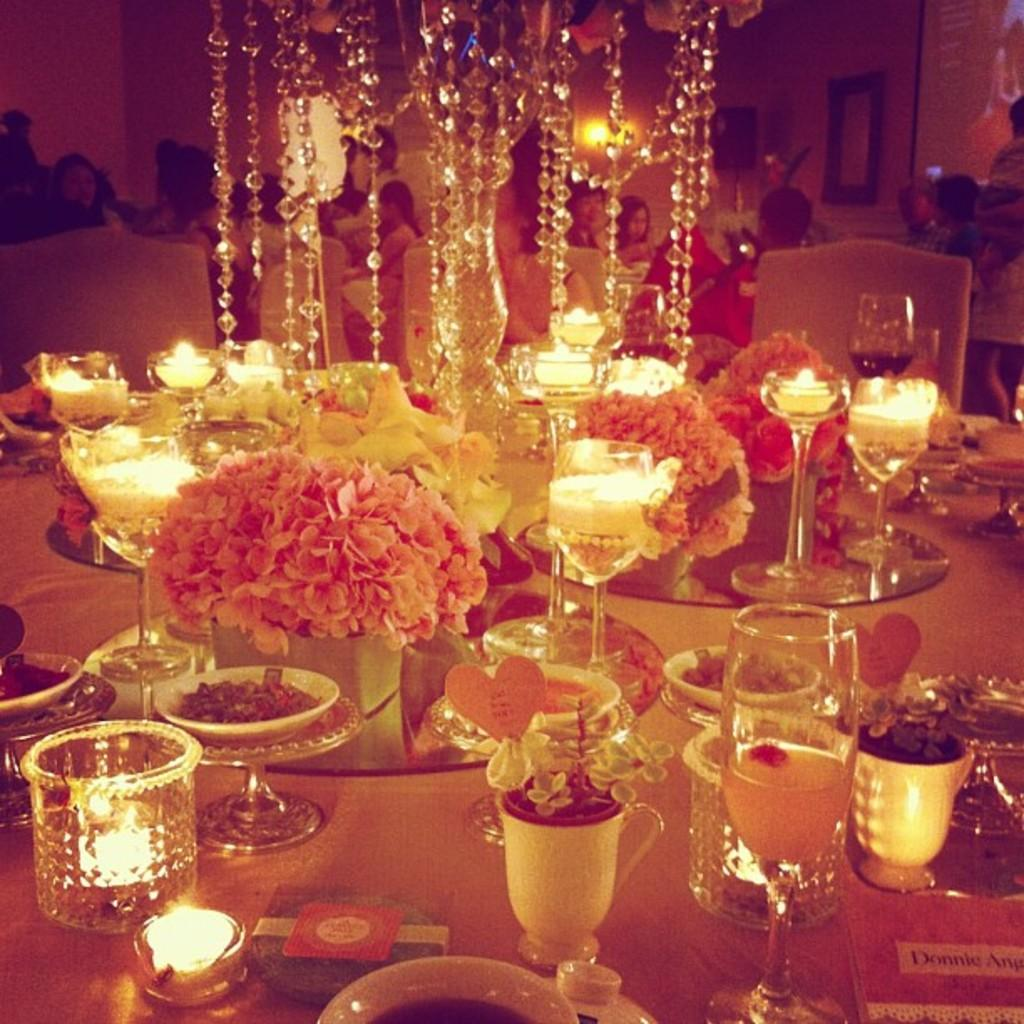What are the people in the image doing? There are people seated on chairs in the image, which suggests they might be attending classes. What objects can be seen on the table in the image? There are plates and bowls on the table in the image. What type of lighting is present in the image? There is a chandelier light in the image. What decorative elements can be seen in the image? Candles and flowers are visible in the image. What type of ring can be seen on the person's finger in the image? There is no ring visible on anyone's finger in the image. What kind of tree is present in the image? There is no tree present in the image. 